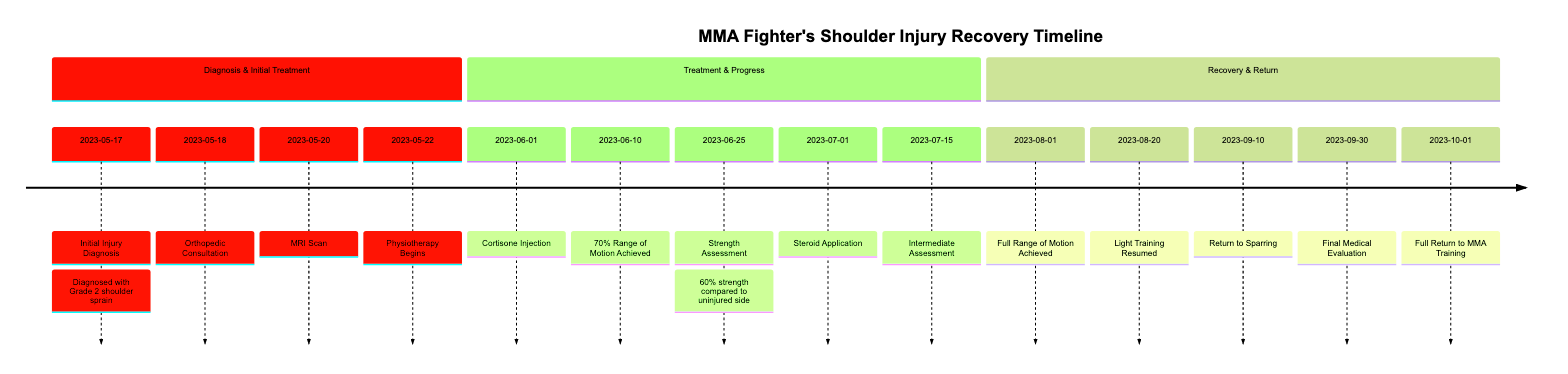What is the first event in the timeline? The first event listed in the timeline is "Initial Injury Diagnosis," which occurs on May 17, 2023. This is the starting point of the recovery journey.
Answer: Initial Injury Diagnosis How many days passed between the MRI Scan and the Physiotherapy Begins? The MRI Scan took place on May 20, 2023, and Physiotherapy began on May 22, 2023. The difference in days is 2 days.
Answer: 2 days What percentage of range of motion was achieved on June 10? On June 10, 2023, the timeline indicates that 70% range of motion was achieved compared to the uninjured shoulder.
Answer: 70% Which event marks the full recovery confirmation? The event that confirms full recovery is the "Final Medical Evaluation" on September 30, 2023, where Dr. Stevens confirmed recovery and clearance for full training.
Answer: Final Medical Evaluation What treatment was received on June 1? On June 1, 2023, a Cortisone Injection was received at Riverdale Medical Center to manage inflammation and pain associated with the shoulder injury.
Answer: Cortisone Injection What is the milestone achieved on August 1? On August 1, 2023, the milestone achieved was "Full Range of Motion Achieved," indicating a significant recovery progress in the rehabilitative process.
Answer: Full Range of Motion Achieved How does the strength assessment on June 25 compare to the uninjured shoulder? The strength assessment conducted on June 25, 2023, showed 60% strength compared to the uninjured side, indicating an improvement but still below normal function.
Answer: 60% What date did the fighter begin light training? The fighter resumed light training on August 20, 2023, marking a crucial step in the reintegration of training routines after recovery.
Answer: August 20, 2023 What were the treatment methods used besides physiotherapy during recovery? Besides physiotherapy, the fighter received a Cortisone Injection, underwent a strength assessment, and applied a localized steroid cream as treatment methods during recovery.
Answer: Cortisone Injection and Steroid Application 